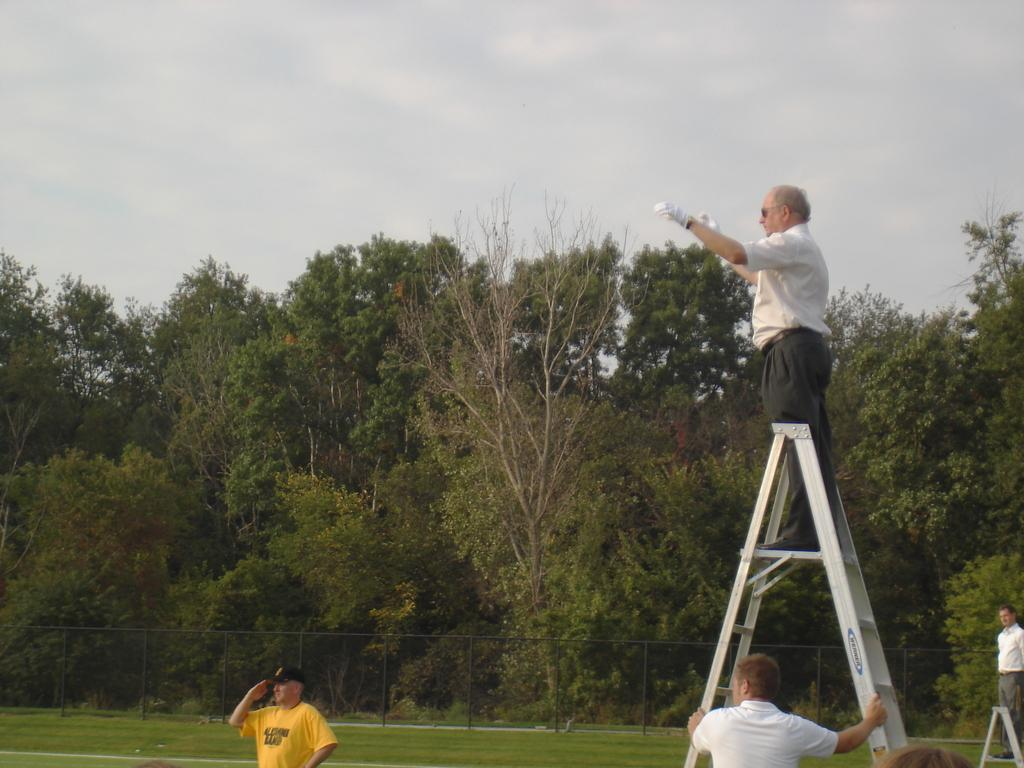How many people are in the image? There are people in the image, but the exact number is not specified. What type of clothing accessories are some people wearing? Some people are wearing caps, gloves, and goggles. What type of vegetation is present in the image? There is grass, trees, and a fence in the image. What is the condition of the sky in the image? The sky is cloudy in the image. What type of arch can be seen in the image? There is no arch present in the image. What type of farming equipment is being used by the farmer in the image? There is no farmer or farming equipment present in the image. 